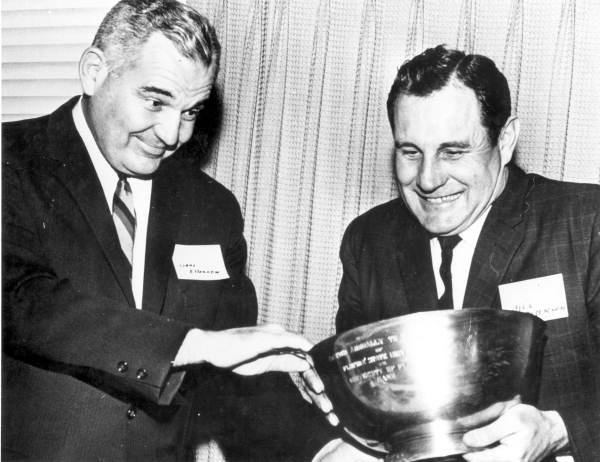Describe the objects in this image and their specific colors. I can see people in white, black, lightgray, gray, and darkgray tones, people in white, black, gray, and darkgray tones, bowl in white, black, gray, and darkgray tones, tie in white, lightgray, gray, black, and darkgray tones, and tie in white, black, gray, darkgray, and lightgray tones in this image. 